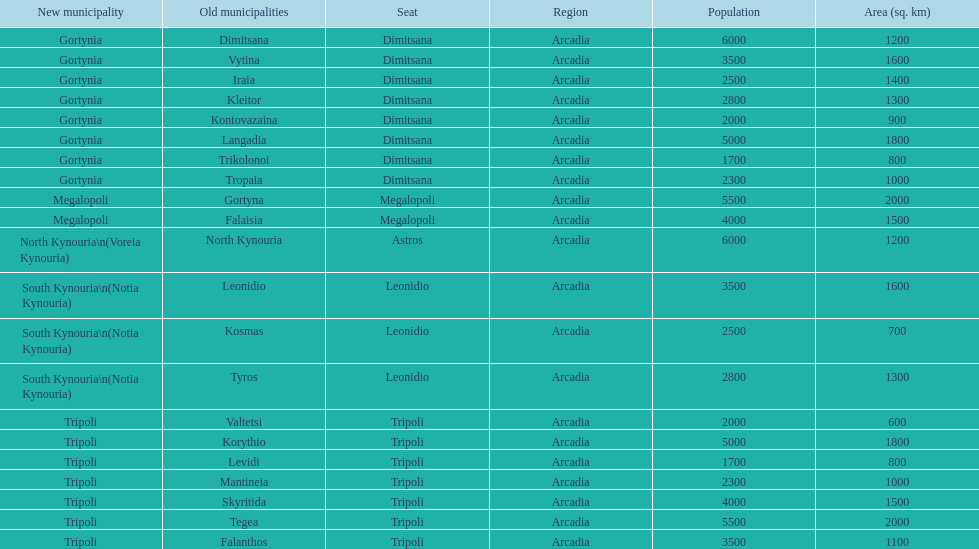Is tripoli still considered a municipality in arcadia since its 2011 reformation? Yes. Would you mind parsing the complete table? {'header': ['New municipality', 'Old municipalities', 'Seat', 'Region', 'Population', 'Area (sq. km)'], 'rows': [['Gortynia', 'Dimitsana', 'Dimitsana', 'Arcadia', '6000', '1200'], ['Gortynia', 'Vytina', 'Dimitsana', 'Arcadia', '3500', '1600'], ['Gortynia', 'Iraia', 'Dimitsana', 'Arcadia', '2500', '1400'], ['Gortynia', 'Kleitor', 'Dimitsana', 'Arcadia', '2800', '1300'], ['Gortynia', 'Kontovazaina', 'Dimitsana', 'Arcadia', '2000', '900'], ['Gortynia', 'Langadia', 'Dimitsana', 'Arcadia', '5000', '1800'], ['Gortynia', 'Trikolonoi', 'Dimitsana', 'Arcadia', '1700', '800'], ['Gortynia', 'Tropaia', 'Dimitsana', 'Arcadia', '2300', '1000'], ['Megalopoli', 'Gortyna', 'Megalopoli', 'Arcadia', '5500', '2000'], ['Megalopoli', 'Falaisia', 'Megalopoli', 'Arcadia', '4000', '1500'], ['North Kynouria\\n(Voreia Kynouria)', 'North Kynouria', 'Astros', 'Arcadia', '6000', '1200'], ['South Kynouria\\n(Notia Kynouria)', 'Leonidio', 'Leonidio', 'Arcadia', '3500', '1600'], ['South Kynouria\\n(Notia Kynouria)', 'Kosmas', 'Leonidio', 'Arcadia', '2500', '700'], ['South Kynouria\\n(Notia Kynouria)', 'Tyros', 'Leonidio', 'Arcadia', '2800', '1300'], ['Tripoli', 'Valtetsi', 'Tripoli', 'Arcadia', '2000', '600'], ['Tripoli', 'Korythio', 'Tripoli', 'Arcadia', '5000', '1800'], ['Tripoli', 'Levidi', 'Tripoli', 'Arcadia', '1700', '800'], ['Tripoli', 'Mantineia', 'Tripoli', 'Arcadia', '2300', '1000'], ['Tripoli', 'Skyritida', 'Tripoli', 'Arcadia', '4000', '1500'], ['Tripoli', 'Tegea', 'Tripoli', 'Arcadia', '5500', '2000'], ['Tripoli', 'Falanthos', 'Tripoli', 'Arcadia', '3500', '1100']]} 